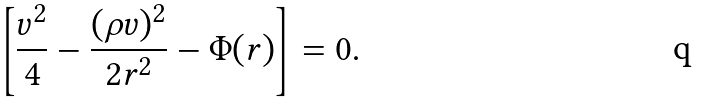Convert formula to latex. <formula><loc_0><loc_0><loc_500><loc_500>\left [ \frac { v ^ { 2 } } { 4 } - \frac { ( \rho v ) ^ { 2 } } { 2 r ^ { 2 } } - \Phi ( r ) \right ] = 0 .</formula> 